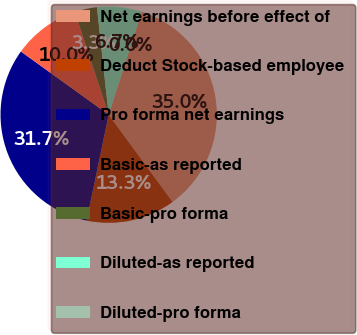Convert chart to OTSL. <chart><loc_0><loc_0><loc_500><loc_500><pie_chart><fcel>Net earnings before effect of<fcel>Deduct Stock-based employee<fcel>Pro forma net earnings<fcel>Basic-as reported<fcel>Basic-pro forma<fcel>Diluted-as reported<fcel>Diluted-pro forma<nl><fcel>35.0%<fcel>13.33%<fcel>31.67%<fcel>10.0%<fcel>3.33%<fcel>6.67%<fcel>0.0%<nl></chart> 